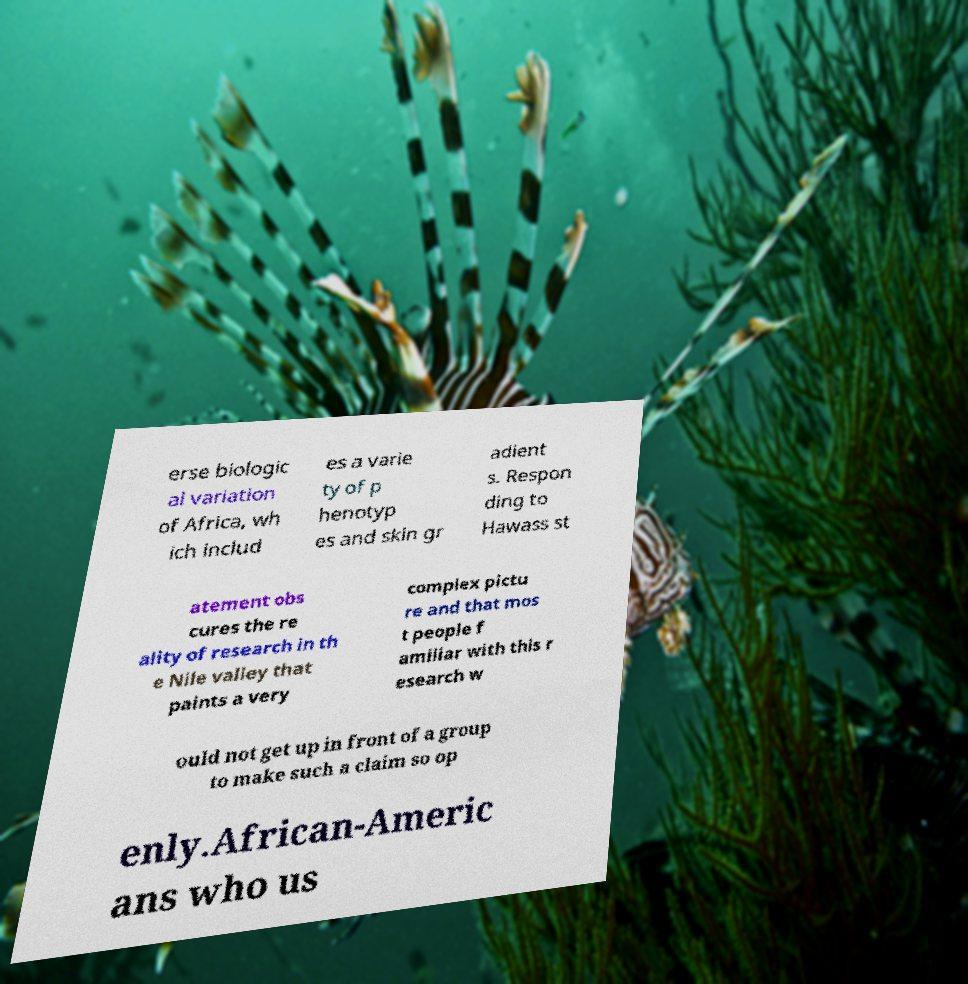For documentation purposes, I need the text within this image transcribed. Could you provide that? erse biologic al variation of Africa, wh ich includ es a varie ty of p henotyp es and skin gr adient s. Respon ding to Hawass st atement obs cures the re ality of research in th e Nile valley that paints a very complex pictu re and that mos t people f amiliar with this r esearch w ould not get up in front of a group to make such a claim so op enly.African-Americ ans who us 